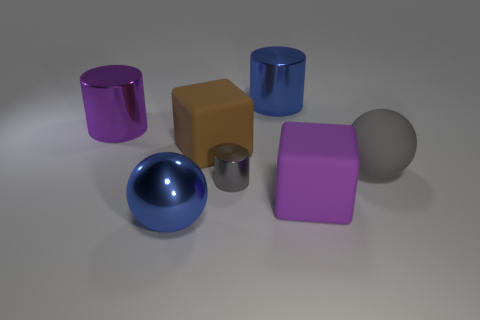Add 1 brown rubber spheres. How many objects exist? 8 Subtract all balls. How many objects are left? 5 Add 5 brown rubber cubes. How many brown rubber cubes exist? 6 Subtract 1 purple blocks. How many objects are left? 6 Subtract all large brown blocks. Subtract all big metallic balls. How many objects are left? 5 Add 1 large purple metal things. How many large purple metal things are left? 2 